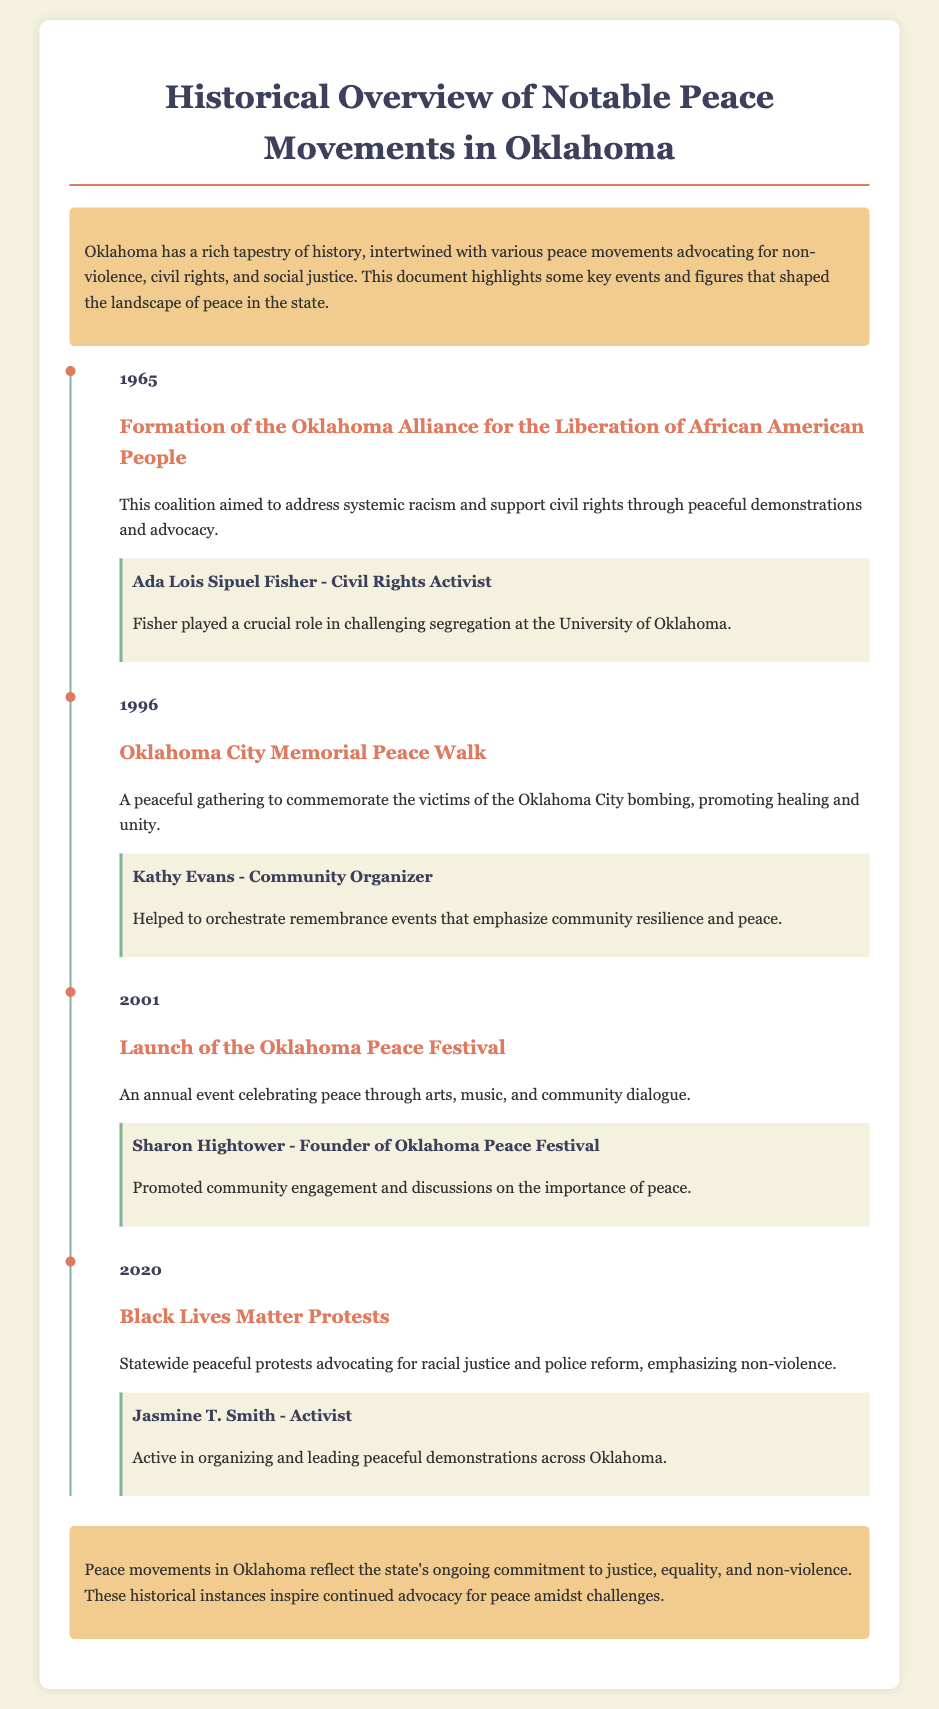what year was the Oklahoma Alliance for the Liberation of African American People formed? The document states that the Oklahoma Alliance for the Liberation of African American People was formed in 1965.
Answer: 1965 who was a key figure in the 1996 Oklahoma City Memorial Peace Walk? The document highlights Kathy Evans as a key figure in the 1996 Oklahoma City Memorial Peace Walk.
Answer: Kathy Evans what is the name of the annual event that celebrates peace starting in 2001? The document refers to the annual event as the Oklahoma Peace Festival that began in 2001.
Answer: Oklahoma Peace Festival which notable movement took place in 2020? The document mentions the Black Lives Matter Protests as the notable movement that took place in 2020.
Answer: Black Lives Matter Protests what is a primary focus of the Oklahoma Peace Festival? The document indicates that the Oklahoma Peace Festival focuses on celebrating peace through arts, music, and community dialogue.
Answer: Arts, music, and community dialogue who was actively involved in the Black Lives Matter Protests? According to the document, Jasmine T. Smith was actively involved in the Black Lives Matter Protests.
Answer: Jasmine T. Smith how many key figures are associated with the events in the timeline? The document includes four key figures associated with the events in the timeline.
Answer: Four what does the conclusion of the document emphasize? The conclusion highlights the ongoing commitment to justice, equality, and non-violence in Oklahoma.
Answer: Justice, equality, and non-violence 